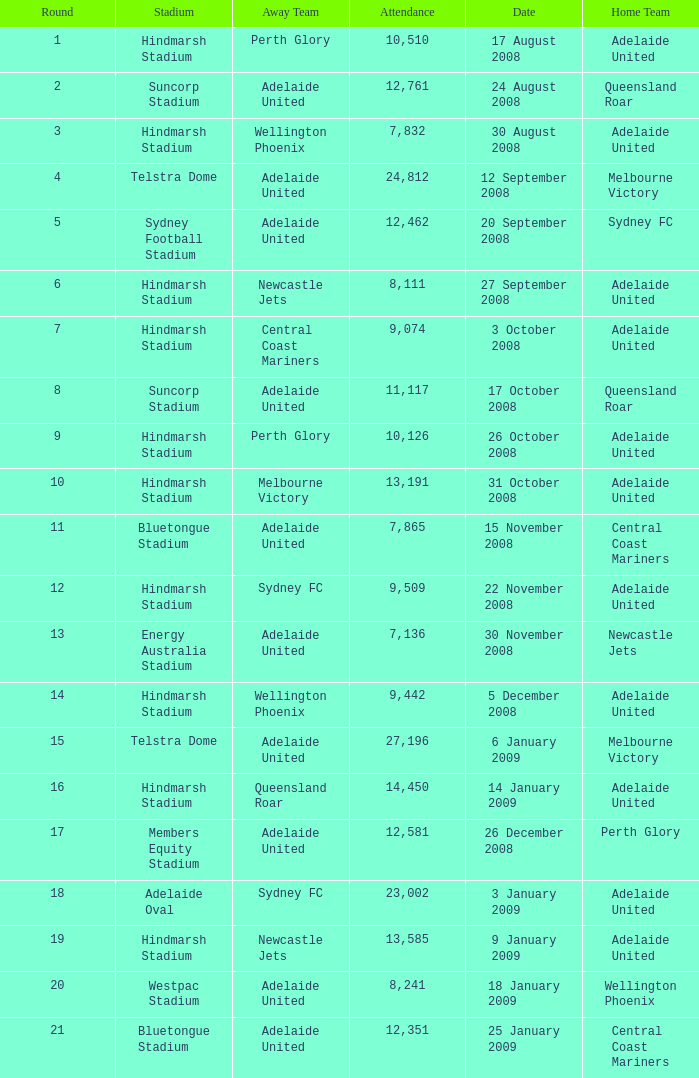Who was the away team when Queensland Roar was the home team in the round less than 3? Adelaide United. 